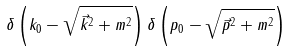Convert formula to latex. <formula><loc_0><loc_0><loc_500><loc_500>\delta \left ( k _ { 0 } - \sqrt { \vec { k } ^ { 2 } + m ^ { 2 } } \right ) \delta \left ( p _ { 0 } - \sqrt { \vec { p } ^ { 2 } + m ^ { 2 } } \right )</formula> 